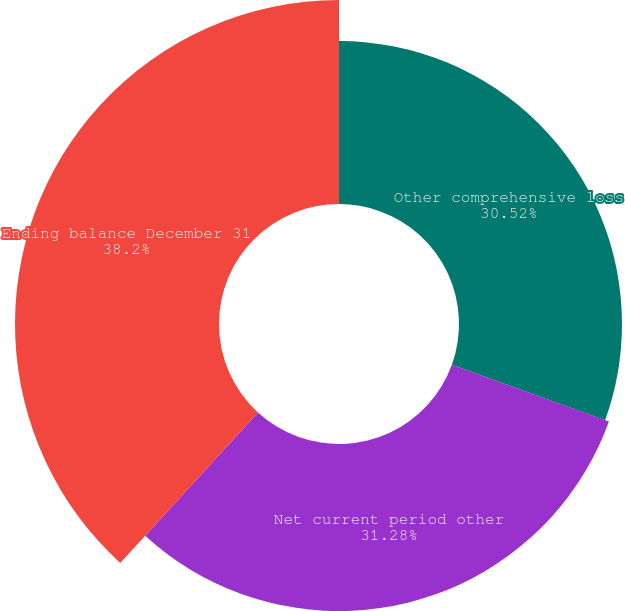Convert chart. <chart><loc_0><loc_0><loc_500><loc_500><pie_chart><fcel>Other comprehensive loss<fcel>Net current period other<fcel>Ending balance December 31<nl><fcel>30.52%<fcel>31.28%<fcel>38.2%<nl></chart> 